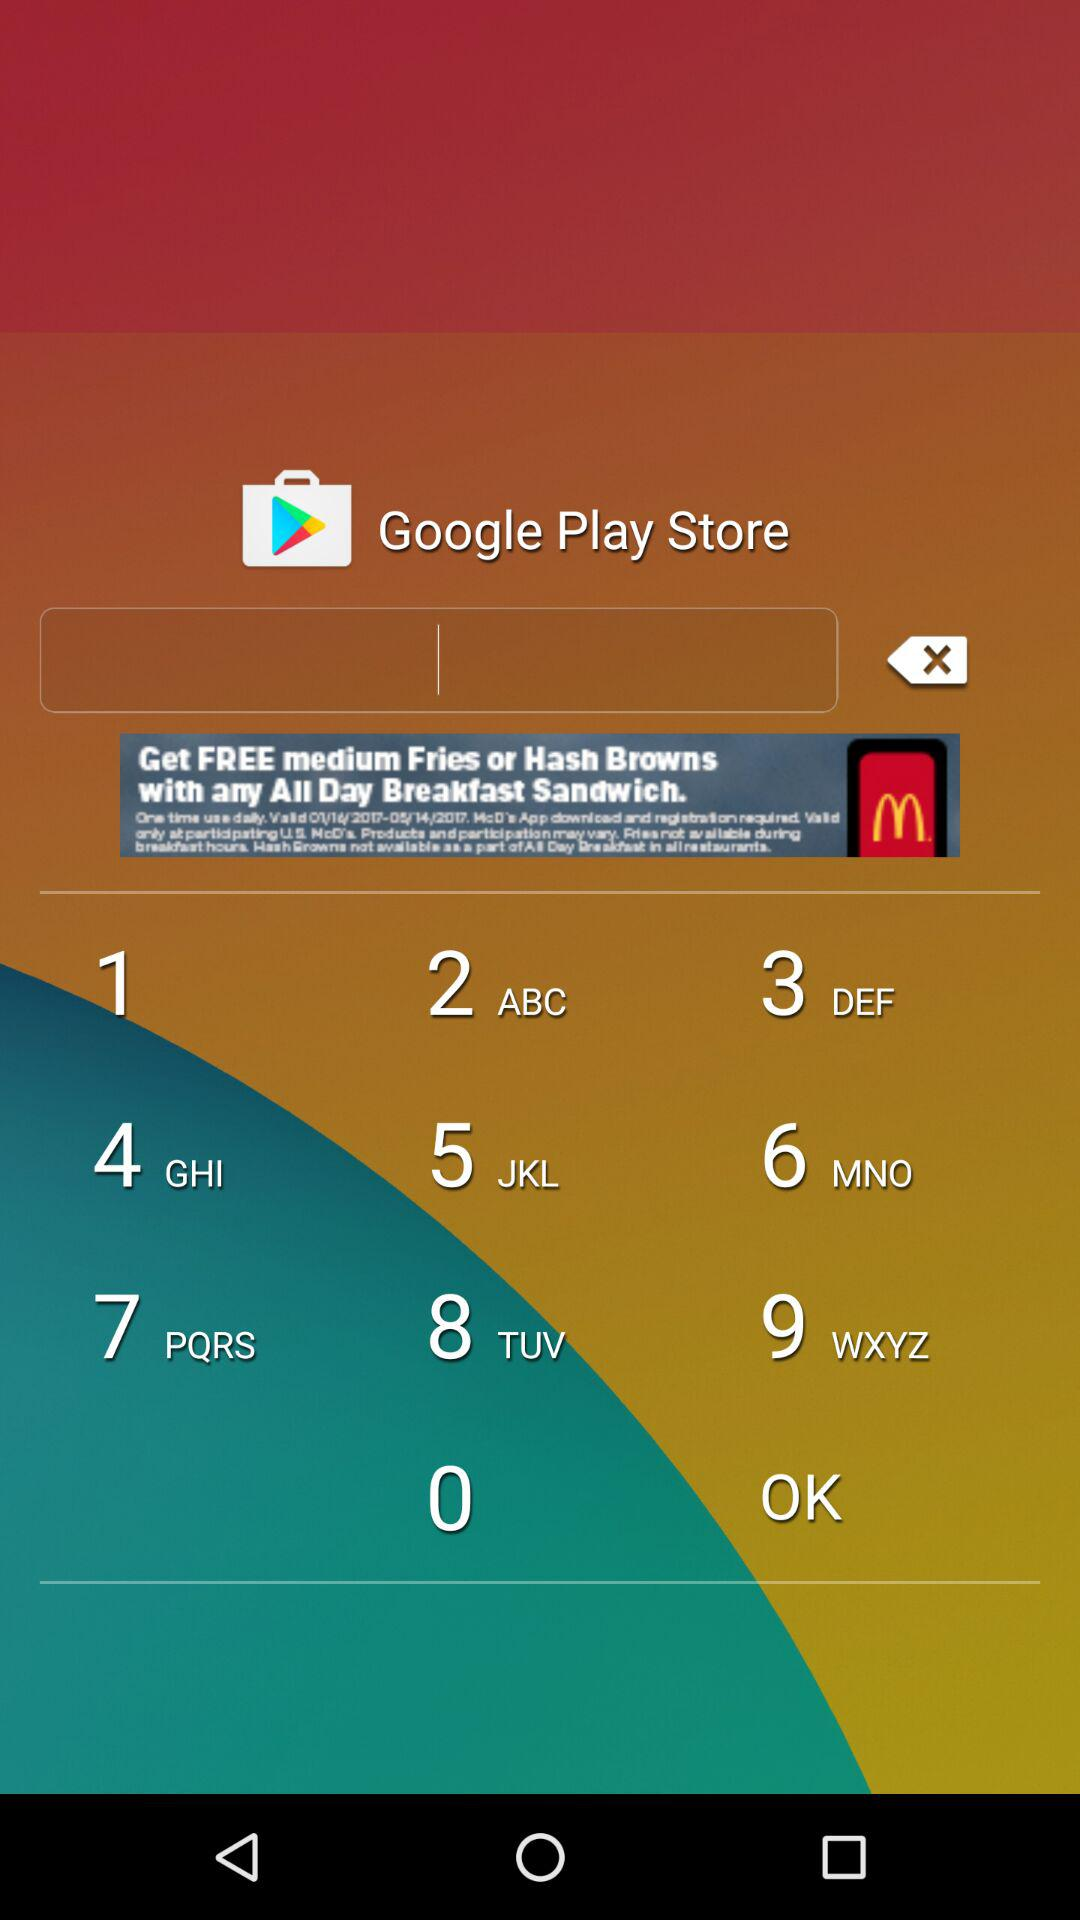What is the name of the application? The name of the application is "Bubble Shooter Deluxe". 